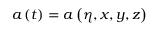Convert formula to latex. <formula><loc_0><loc_0><loc_500><loc_500>a \left ( t \right ) = a \left ( \eta , x , y , z \right )</formula> 